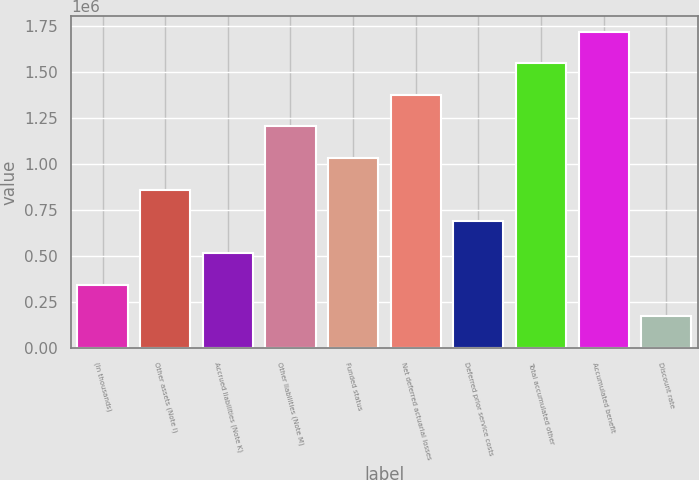Convert chart to OTSL. <chart><loc_0><loc_0><loc_500><loc_500><bar_chart><fcel>(In thousands)<fcel>Other assets (Note I)<fcel>Accrued liabilities (Note K)<fcel>Other liabilities (Note M)<fcel>Funded status<fcel>Net deferred actuarial losses<fcel>Deferred prior service costs<fcel>Total accumulated other<fcel>Accumulated benefit<fcel>Discount rate<nl><fcel>343560<fcel>858895<fcel>515338<fcel>1.20245e+06<fcel>1.03067e+06<fcel>1.37423e+06<fcel>687117<fcel>1.54601e+06<fcel>1.71779e+06<fcel>171782<nl></chart> 